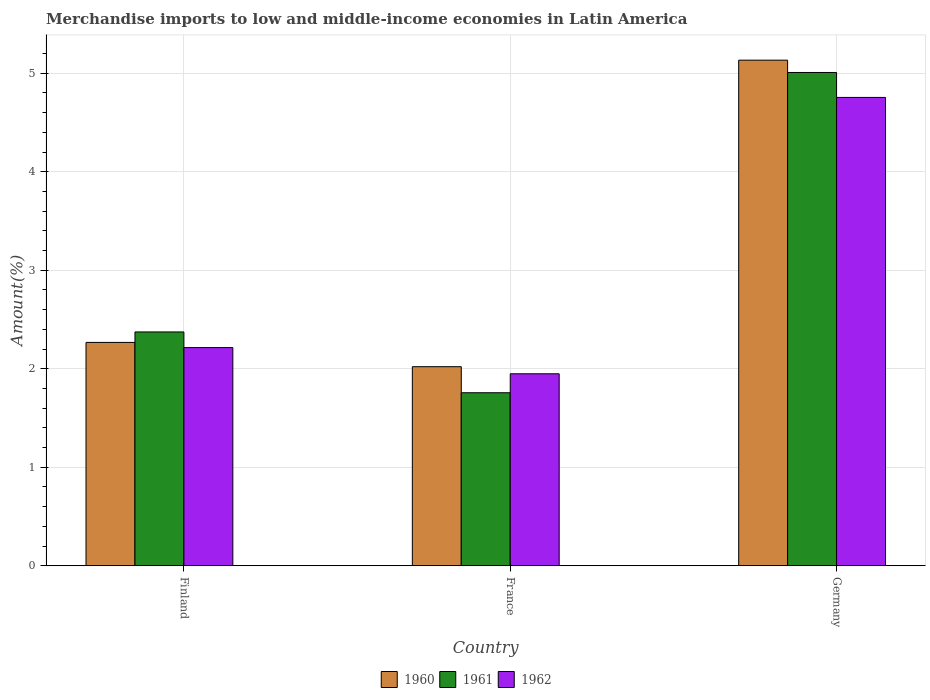How many different coloured bars are there?
Your response must be concise. 3. How many groups of bars are there?
Your answer should be compact. 3. Are the number of bars per tick equal to the number of legend labels?
Keep it short and to the point. Yes. In how many cases, is the number of bars for a given country not equal to the number of legend labels?
Your response must be concise. 0. What is the percentage of amount earned from merchandise imports in 1960 in Germany?
Make the answer very short. 5.13. Across all countries, what is the maximum percentage of amount earned from merchandise imports in 1960?
Your answer should be compact. 5.13. Across all countries, what is the minimum percentage of amount earned from merchandise imports in 1962?
Offer a terse response. 1.95. What is the total percentage of amount earned from merchandise imports in 1962 in the graph?
Offer a terse response. 8.92. What is the difference between the percentage of amount earned from merchandise imports in 1962 in Finland and that in Germany?
Your answer should be very brief. -2.54. What is the difference between the percentage of amount earned from merchandise imports in 1961 in France and the percentage of amount earned from merchandise imports in 1960 in Finland?
Your answer should be compact. -0.51. What is the average percentage of amount earned from merchandise imports in 1962 per country?
Your answer should be compact. 2.97. What is the difference between the percentage of amount earned from merchandise imports of/in 1962 and percentage of amount earned from merchandise imports of/in 1961 in Finland?
Your response must be concise. -0.16. In how many countries, is the percentage of amount earned from merchandise imports in 1961 greater than 0.4 %?
Provide a succinct answer. 3. What is the ratio of the percentage of amount earned from merchandise imports in 1961 in Finland to that in France?
Make the answer very short. 1.35. Is the percentage of amount earned from merchandise imports in 1962 in Finland less than that in France?
Your answer should be very brief. No. What is the difference between the highest and the second highest percentage of amount earned from merchandise imports in 1961?
Make the answer very short. -0.62. What is the difference between the highest and the lowest percentage of amount earned from merchandise imports in 1961?
Give a very brief answer. 3.25. Is it the case that in every country, the sum of the percentage of amount earned from merchandise imports in 1961 and percentage of amount earned from merchandise imports in 1962 is greater than the percentage of amount earned from merchandise imports in 1960?
Your response must be concise. Yes. Are the values on the major ticks of Y-axis written in scientific E-notation?
Keep it short and to the point. No. Does the graph contain grids?
Offer a very short reply. Yes. Where does the legend appear in the graph?
Your response must be concise. Bottom center. How many legend labels are there?
Your answer should be very brief. 3. How are the legend labels stacked?
Your response must be concise. Horizontal. What is the title of the graph?
Provide a succinct answer. Merchandise imports to low and middle-income economies in Latin America. What is the label or title of the X-axis?
Provide a succinct answer. Country. What is the label or title of the Y-axis?
Give a very brief answer. Amount(%). What is the Amount(%) of 1960 in Finland?
Your answer should be compact. 2.27. What is the Amount(%) of 1961 in Finland?
Provide a succinct answer. 2.37. What is the Amount(%) of 1962 in Finland?
Your response must be concise. 2.22. What is the Amount(%) in 1960 in France?
Offer a very short reply. 2.02. What is the Amount(%) in 1961 in France?
Your response must be concise. 1.76. What is the Amount(%) in 1962 in France?
Your response must be concise. 1.95. What is the Amount(%) in 1960 in Germany?
Your answer should be very brief. 5.13. What is the Amount(%) in 1961 in Germany?
Your answer should be compact. 5.01. What is the Amount(%) of 1962 in Germany?
Your response must be concise. 4.75. Across all countries, what is the maximum Amount(%) of 1960?
Your answer should be compact. 5.13. Across all countries, what is the maximum Amount(%) of 1961?
Keep it short and to the point. 5.01. Across all countries, what is the maximum Amount(%) of 1962?
Give a very brief answer. 4.75. Across all countries, what is the minimum Amount(%) in 1960?
Provide a short and direct response. 2.02. Across all countries, what is the minimum Amount(%) of 1961?
Offer a very short reply. 1.76. Across all countries, what is the minimum Amount(%) of 1962?
Give a very brief answer. 1.95. What is the total Amount(%) of 1960 in the graph?
Provide a succinct answer. 9.42. What is the total Amount(%) of 1961 in the graph?
Offer a terse response. 9.14. What is the total Amount(%) in 1962 in the graph?
Your answer should be compact. 8.92. What is the difference between the Amount(%) in 1960 in Finland and that in France?
Give a very brief answer. 0.25. What is the difference between the Amount(%) of 1961 in Finland and that in France?
Keep it short and to the point. 0.62. What is the difference between the Amount(%) of 1962 in Finland and that in France?
Your response must be concise. 0.27. What is the difference between the Amount(%) of 1960 in Finland and that in Germany?
Your response must be concise. -2.87. What is the difference between the Amount(%) in 1961 in Finland and that in Germany?
Make the answer very short. -2.63. What is the difference between the Amount(%) in 1962 in Finland and that in Germany?
Offer a very short reply. -2.54. What is the difference between the Amount(%) in 1960 in France and that in Germany?
Your answer should be compact. -3.11. What is the difference between the Amount(%) of 1961 in France and that in Germany?
Your answer should be compact. -3.25. What is the difference between the Amount(%) of 1962 in France and that in Germany?
Give a very brief answer. -2.81. What is the difference between the Amount(%) in 1960 in Finland and the Amount(%) in 1961 in France?
Ensure brevity in your answer.  0.51. What is the difference between the Amount(%) of 1960 in Finland and the Amount(%) of 1962 in France?
Ensure brevity in your answer.  0.32. What is the difference between the Amount(%) in 1961 in Finland and the Amount(%) in 1962 in France?
Provide a short and direct response. 0.42. What is the difference between the Amount(%) in 1960 in Finland and the Amount(%) in 1961 in Germany?
Make the answer very short. -2.74. What is the difference between the Amount(%) in 1960 in Finland and the Amount(%) in 1962 in Germany?
Your answer should be compact. -2.49. What is the difference between the Amount(%) in 1961 in Finland and the Amount(%) in 1962 in Germany?
Your response must be concise. -2.38. What is the difference between the Amount(%) in 1960 in France and the Amount(%) in 1961 in Germany?
Your answer should be very brief. -2.99. What is the difference between the Amount(%) in 1960 in France and the Amount(%) in 1962 in Germany?
Give a very brief answer. -2.73. What is the difference between the Amount(%) of 1961 in France and the Amount(%) of 1962 in Germany?
Make the answer very short. -3. What is the average Amount(%) in 1960 per country?
Give a very brief answer. 3.14. What is the average Amount(%) of 1961 per country?
Keep it short and to the point. 3.05. What is the average Amount(%) of 1962 per country?
Provide a short and direct response. 2.97. What is the difference between the Amount(%) of 1960 and Amount(%) of 1961 in Finland?
Your response must be concise. -0.11. What is the difference between the Amount(%) of 1960 and Amount(%) of 1962 in Finland?
Your answer should be compact. 0.05. What is the difference between the Amount(%) of 1961 and Amount(%) of 1962 in Finland?
Ensure brevity in your answer.  0.16. What is the difference between the Amount(%) in 1960 and Amount(%) in 1961 in France?
Ensure brevity in your answer.  0.26. What is the difference between the Amount(%) in 1960 and Amount(%) in 1962 in France?
Your answer should be compact. 0.07. What is the difference between the Amount(%) in 1961 and Amount(%) in 1962 in France?
Your answer should be compact. -0.19. What is the difference between the Amount(%) in 1960 and Amount(%) in 1961 in Germany?
Offer a very short reply. 0.13. What is the difference between the Amount(%) in 1960 and Amount(%) in 1962 in Germany?
Your answer should be very brief. 0.38. What is the difference between the Amount(%) of 1961 and Amount(%) of 1962 in Germany?
Make the answer very short. 0.25. What is the ratio of the Amount(%) in 1960 in Finland to that in France?
Offer a very short reply. 1.12. What is the ratio of the Amount(%) in 1961 in Finland to that in France?
Your answer should be very brief. 1.35. What is the ratio of the Amount(%) of 1962 in Finland to that in France?
Keep it short and to the point. 1.14. What is the ratio of the Amount(%) in 1960 in Finland to that in Germany?
Give a very brief answer. 0.44. What is the ratio of the Amount(%) in 1961 in Finland to that in Germany?
Make the answer very short. 0.47. What is the ratio of the Amount(%) in 1962 in Finland to that in Germany?
Ensure brevity in your answer.  0.47. What is the ratio of the Amount(%) in 1960 in France to that in Germany?
Keep it short and to the point. 0.39. What is the ratio of the Amount(%) of 1961 in France to that in Germany?
Provide a short and direct response. 0.35. What is the ratio of the Amount(%) of 1962 in France to that in Germany?
Provide a short and direct response. 0.41. What is the difference between the highest and the second highest Amount(%) of 1960?
Offer a very short reply. 2.87. What is the difference between the highest and the second highest Amount(%) in 1961?
Give a very brief answer. 2.63. What is the difference between the highest and the second highest Amount(%) in 1962?
Ensure brevity in your answer.  2.54. What is the difference between the highest and the lowest Amount(%) in 1960?
Your answer should be very brief. 3.11. What is the difference between the highest and the lowest Amount(%) in 1961?
Keep it short and to the point. 3.25. What is the difference between the highest and the lowest Amount(%) in 1962?
Give a very brief answer. 2.81. 